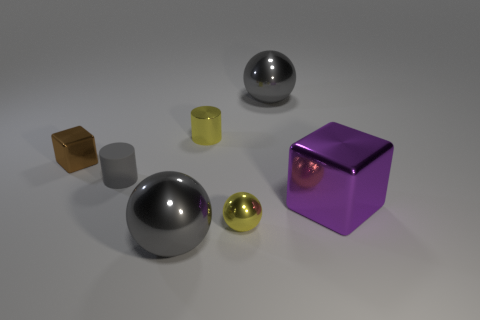Which of these objects is the most reflective? The most reflective object appears to be the sphere on the right with a mirror-like surface that clearly reflects the environment. 